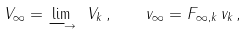<formula> <loc_0><loc_0><loc_500><loc_500>V _ { \infty } = \underset { \longrightarrow } { \lim } \ V _ { k } \, , \quad v _ { \infty } = F _ { \infty , k } \, v _ { k } \, ,</formula> 